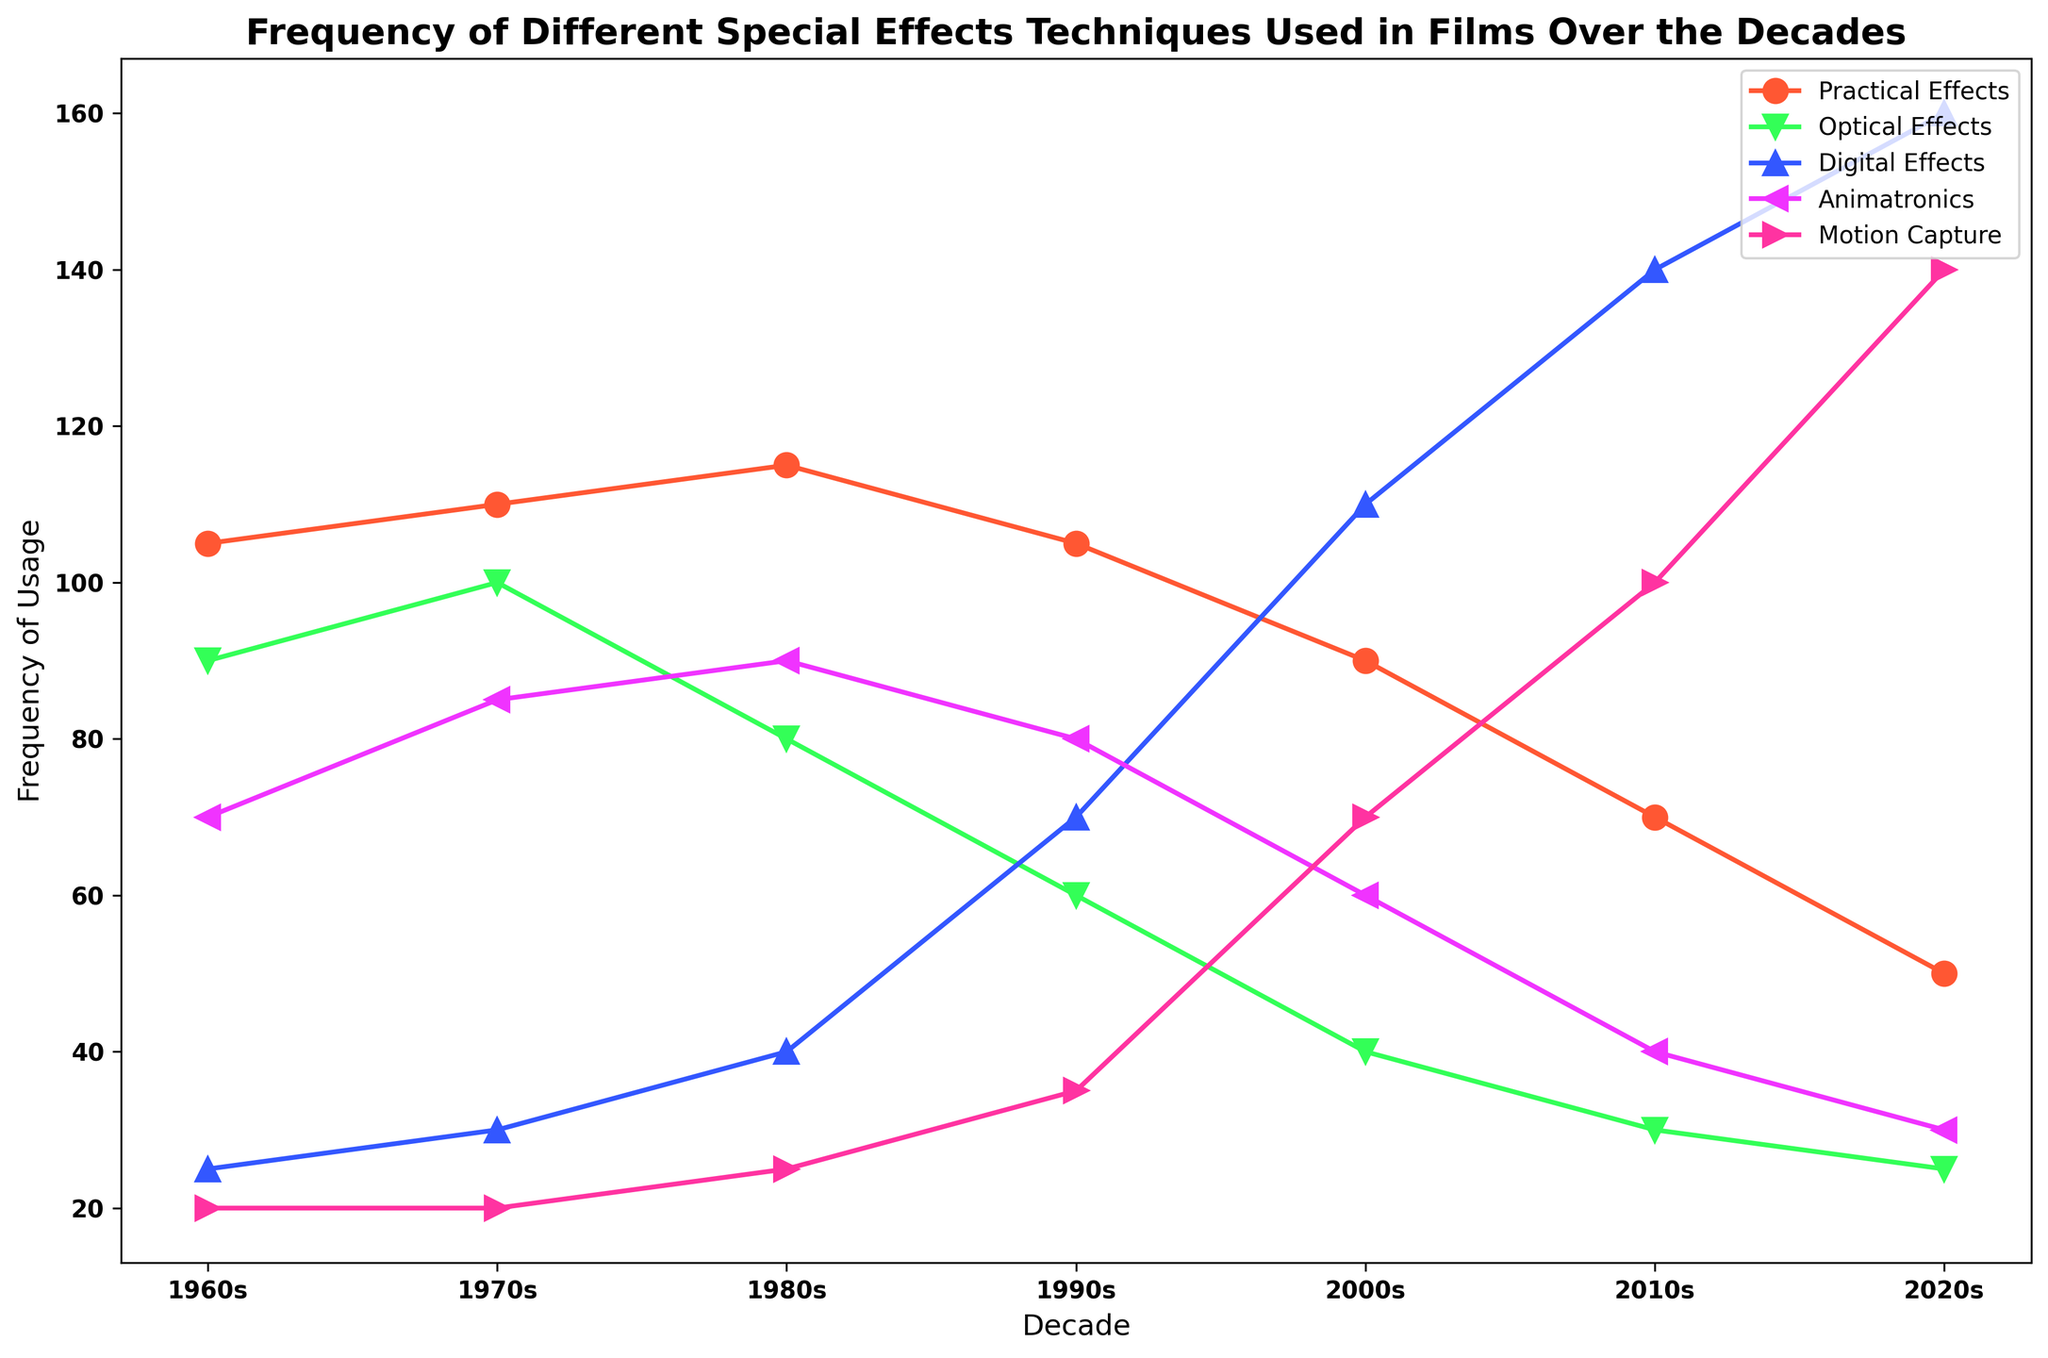What special effects technique had the highest frequency of usage in the 1960s? Look at the plot for the decade labeled 1960s and find the technique with the tallest line or marker.
Answer: Practical effects How has the usage of motion capture evolved from the 1980s to the 2020s? Compare the frequency values for motion capture for the decades 1980s and 2020s by looking at the markers or lines corresponding to each decade.
Answer: Increased What is the most noticeable trend in the usage of digital effects? Analyze the line or markers representing digital effects across all the decades, looking for an increasing or decreasing trend.
Answer: Increasing By how much has the usage frequency of optical effects decreased from the 1970s to the 2010s? Find the frequency values of optical effects for the decades 1970s and 2010s and calculate the difference.
Answer: Decreased by 70 Which decade saw the highest combined frequency for practical and animatronic effects? Calculate the sum of practical and animatronic effect values for each decade and identify the decade with the highest sum.
Answer: 1980s What can be inferred about the usage of optical effects and digital effects from the 1990s to the 2020s? Compare the trends of optical and digital effects between these decades. Optical effects should show a decreasing trend, while digital effects should show an increasing trend.
Answer: Optical effects decreased, digital effects increased What is the average frequency of usage for animatronics over all surveyed decades? Add up the frequencies of animatronics across all decades and divide by the number of decades. (50+65+70+60+40+20+10)/7 = 315/7
Answer: 45 Which special effects technique showed a significant rise in usage frequency in the 2010s, compared to the previous decades? Identify which technique has a marker or line that shows a sudden and significant increase in height in the 2010s.
Answer: Motion capture If you summed the frequency of digital effects used in the 1990s and the 2000s, what would be the result? Add the frequency values for digital effects in the 1990s and 2000s. (50+90)
Answer: 140 How did the usage of practical effects change from the 1970s to the 2020s? Compare the frequency values of practical effects between these two decades.
Answer: Decreased from 90 to 30 